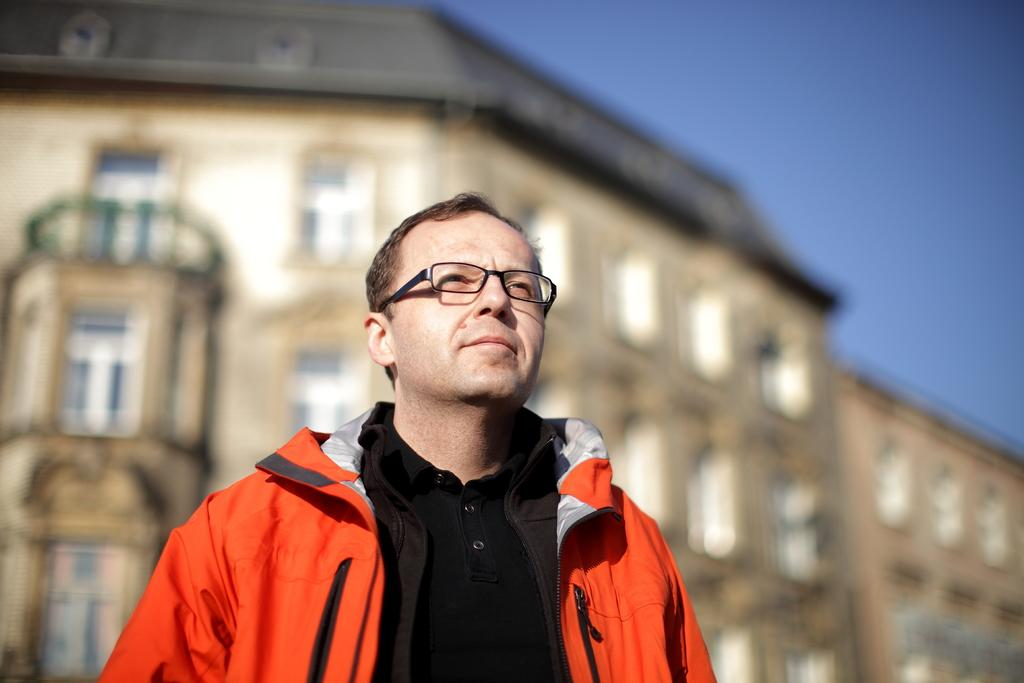What is the main subject of the image? There is a person standing in the image. What is the person wearing? The person is wearing a black and orange color dress. What can be seen in the background of the image? There are buildings and windows visible in the background. What is the color of the sky in the image? The sky is blue in color. What type of instrument is the person playing in the image? There is no instrument present in the image; the person is simply standing. Can you tell me if the person's parent is visible in the image? There is no information about the person's parent in the image or the provided facts. 